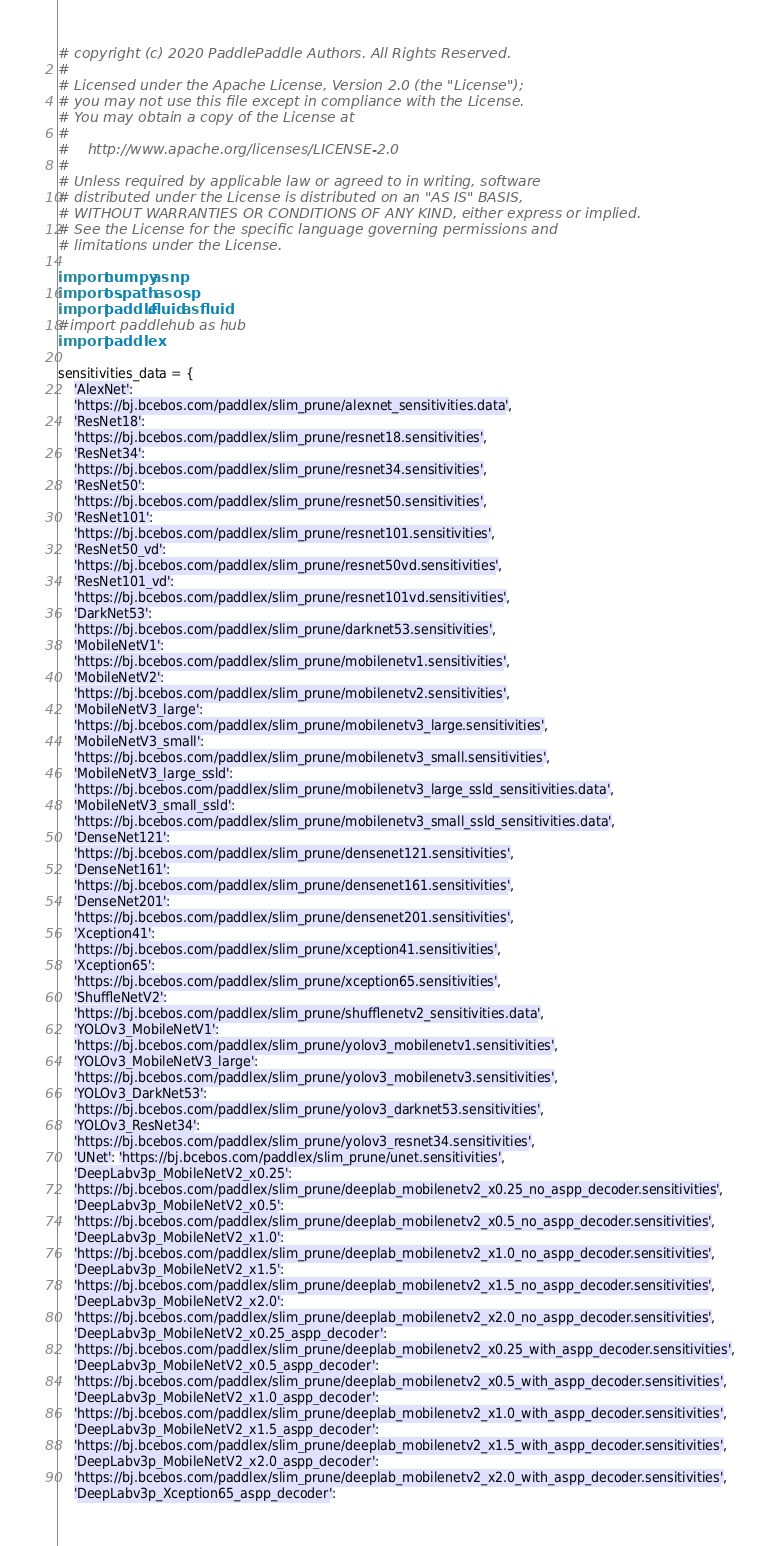<code> <loc_0><loc_0><loc_500><loc_500><_Python_># copyright (c) 2020 PaddlePaddle Authors. All Rights Reserved.
#
# Licensed under the Apache License, Version 2.0 (the "License");
# you may not use this file except in compliance with the License.
# You may obtain a copy of the License at
#
#    http://www.apache.org/licenses/LICENSE-2.0
#
# Unless required by applicable law or agreed to in writing, software
# distributed under the License is distributed on an "AS IS" BASIS,
# WITHOUT WARRANTIES OR CONDITIONS OF ANY KIND, either express or implied.
# See the License for the specific language governing permissions and
# limitations under the License.

import numpy as np
import os.path as osp
import paddle.fluid as fluid
#import paddlehub as hub
import paddlex

sensitivities_data = {
    'AlexNet':
    'https://bj.bcebos.com/paddlex/slim_prune/alexnet_sensitivities.data',
    'ResNet18':
    'https://bj.bcebos.com/paddlex/slim_prune/resnet18.sensitivities',
    'ResNet34':
    'https://bj.bcebos.com/paddlex/slim_prune/resnet34.sensitivities',
    'ResNet50':
    'https://bj.bcebos.com/paddlex/slim_prune/resnet50.sensitivities',
    'ResNet101':
    'https://bj.bcebos.com/paddlex/slim_prune/resnet101.sensitivities',
    'ResNet50_vd':
    'https://bj.bcebos.com/paddlex/slim_prune/resnet50vd.sensitivities',
    'ResNet101_vd':
    'https://bj.bcebos.com/paddlex/slim_prune/resnet101vd.sensitivities',
    'DarkNet53':
    'https://bj.bcebos.com/paddlex/slim_prune/darknet53.sensitivities',
    'MobileNetV1':
    'https://bj.bcebos.com/paddlex/slim_prune/mobilenetv1.sensitivities',
    'MobileNetV2':
    'https://bj.bcebos.com/paddlex/slim_prune/mobilenetv2.sensitivities',
    'MobileNetV3_large':
    'https://bj.bcebos.com/paddlex/slim_prune/mobilenetv3_large.sensitivities',
    'MobileNetV3_small':
    'https://bj.bcebos.com/paddlex/slim_prune/mobilenetv3_small.sensitivities',
    'MobileNetV3_large_ssld':
    'https://bj.bcebos.com/paddlex/slim_prune/mobilenetv3_large_ssld_sensitivities.data',
    'MobileNetV3_small_ssld':
    'https://bj.bcebos.com/paddlex/slim_prune/mobilenetv3_small_ssld_sensitivities.data',
    'DenseNet121':
    'https://bj.bcebos.com/paddlex/slim_prune/densenet121.sensitivities',
    'DenseNet161':
    'https://bj.bcebos.com/paddlex/slim_prune/densenet161.sensitivities',
    'DenseNet201':
    'https://bj.bcebos.com/paddlex/slim_prune/densenet201.sensitivities',
    'Xception41':
    'https://bj.bcebos.com/paddlex/slim_prune/xception41.sensitivities',
    'Xception65':
    'https://bj.bcebos.com/paddlex/slim_prune/xception65.sensitivities',
    'ShuffleNetV2':
    'https://bj.bcebos.com/paddlex/slim_prune/shufflenetv2_sensitivities.data',
    'YOLOv3_MobileNetV1':
    'https://bj.bcebos.com/paddlex/slim_prune/yolov3_mobilenetv1.sensitivities',
    'YOLOv3_MobileNetV3_large':
    'https://bj.bcebos.com/paddlex/slim_prune/yolov3_mobilenetv3.sensitivities',
    'YOLOv3_DarkNet53':
    'https://bj.bcebos.com/paddlex/slim_prune/yolov3_darknet53.sensitivities',
    'YOLOv3_ResNet34':
    'https://bj.bcebos.com/paddlex/slim_prune/yolov3_resnet34.sensitivities',
    'UNet': 'https://bj.bcebos.com/paddlex/slim_prune/unet.sensitivities',
    'DeepLabv3p_MobileNetV2_x0.25':
    'https://bj.bcebos.com/paddlex/slim_prune/deeplab_mobilenetv2_x0.25_no_aspp_decoder.sensitivities',
    'DeepLabv3p_MobileNetV2_x0.5':
    'https://bj.bcebos.com/paddlex/slim_prune/deeplab_mobilenetv2_x0.5_no_aspp_decoder.sensitivities',
    'DeepLabv3p_MobileNetV2_x1.0':
    'https://bj.bcebos.com/paddlex/slim_prune/deeplab_mobilenetv2_x1.0_no_aspp_decoder.sensitivities',
    'DeepLabv3p_MobileNetV2_x1.5':
    'https://bj.bcebos.com/paddlex/slim_prune/deeplab_mobilenetv2_x1.5_no_aspp_decoder.sensitivities',
    'DeepLabv3p_MobileNetV2_x2.0':
    'https://bj.bcebos.com/paddlex/slim_prune/deeplab_mobilenetv2_x2.0_no_aspp_decoder.sensitivities',
    'DeepLabv3p_MobileNetV2_x0.25_aspp_decoder':
    'https://bj.bcebos.com/paddlex/slim_prune/deeplab_mobilenetv2_x0.25_with_aspp_decoder.sensitivities',
    'DeepLabv3p_MobileNetV2_x0.5_aspp_decoder':
    'https://bj.bcebos.com/paddlex/slim_prune/deeplab_mobilenetv2_x0.5_with_aspp_decoder.sensitivities',
    'DeepLabv3p_MobileNetV2_x1.0_aspp_decoder':
    'https://bj.bcebos.com/paddlex/slim_prune/deeplab_mobilenetv2_x1.0_with_aspp_decoder.sensitivities',
    'DeepLabv3p_MobileNetV2_x1.5_aspp_decoder':
    'https://bj.bcebos.com/paddlex/slim_prune/deeplab_mobilenetv2_x1.5_with_aspp_decoder.sensitivities',
    'DeepLabv3p_MobileNetV2_x2.0_aspp_decoder':
    'https://bj.bcebos.com/paddlex/slim_prune/deeplab_mobilenetv2_x2.0_with_aspp_decoder.sensitivities',
    'DeepLabv3p_Xception65_aspp_decoder':</code> 